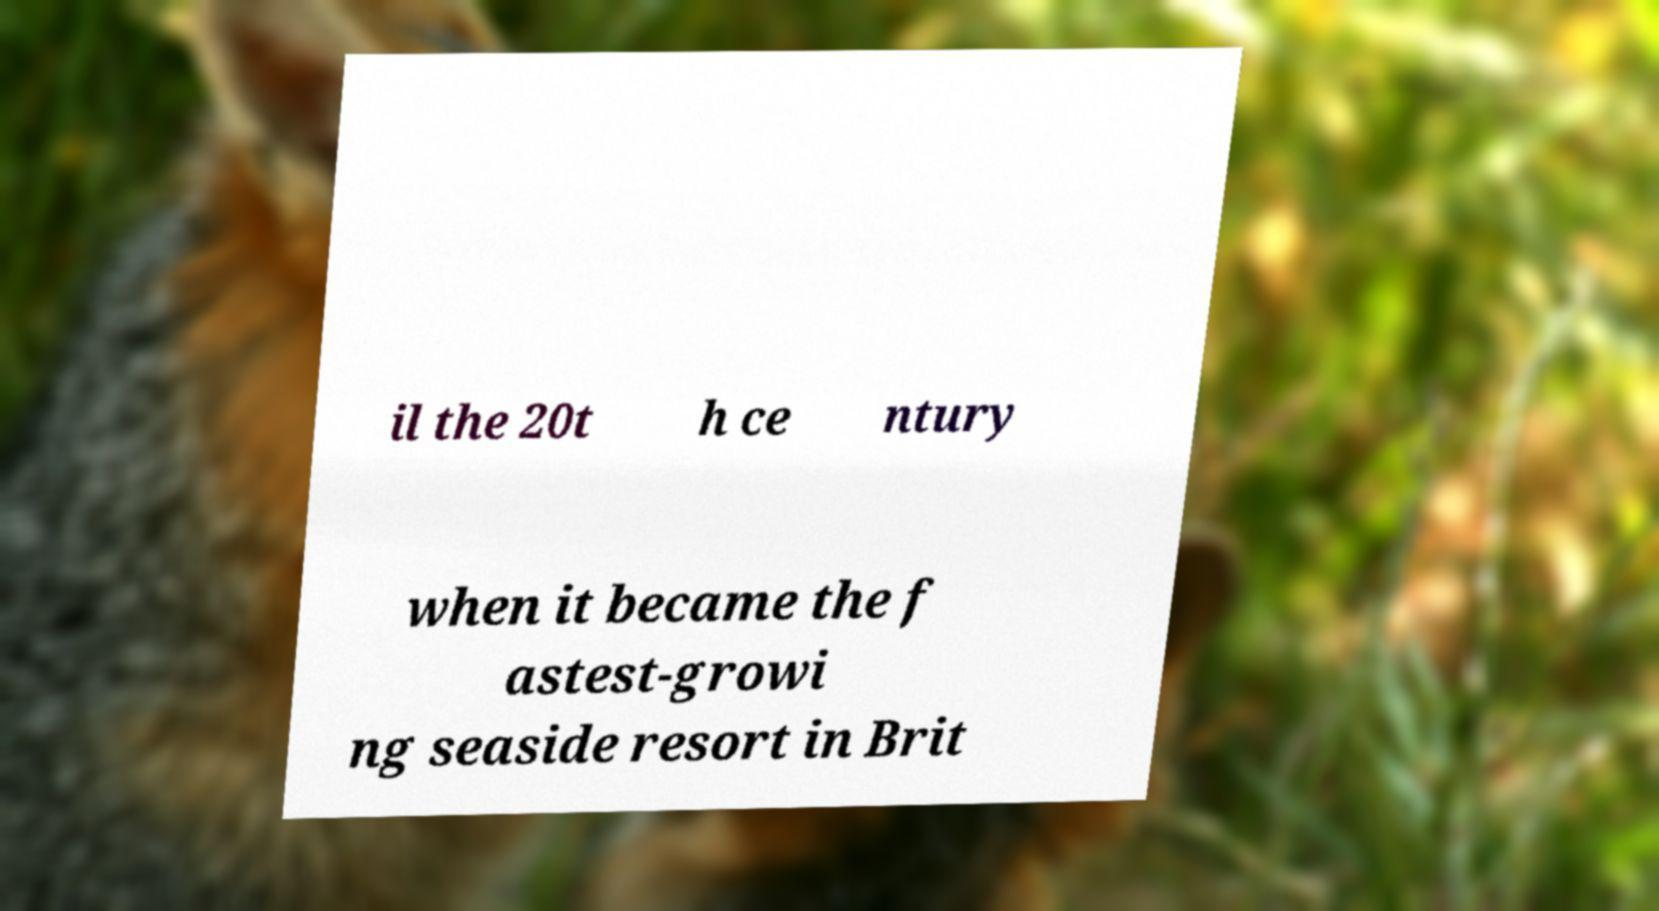Please identify and transcribe the text found in this image. il the 20t h ce ntury when it became the f astest-growi ng seaside resort in Brit 